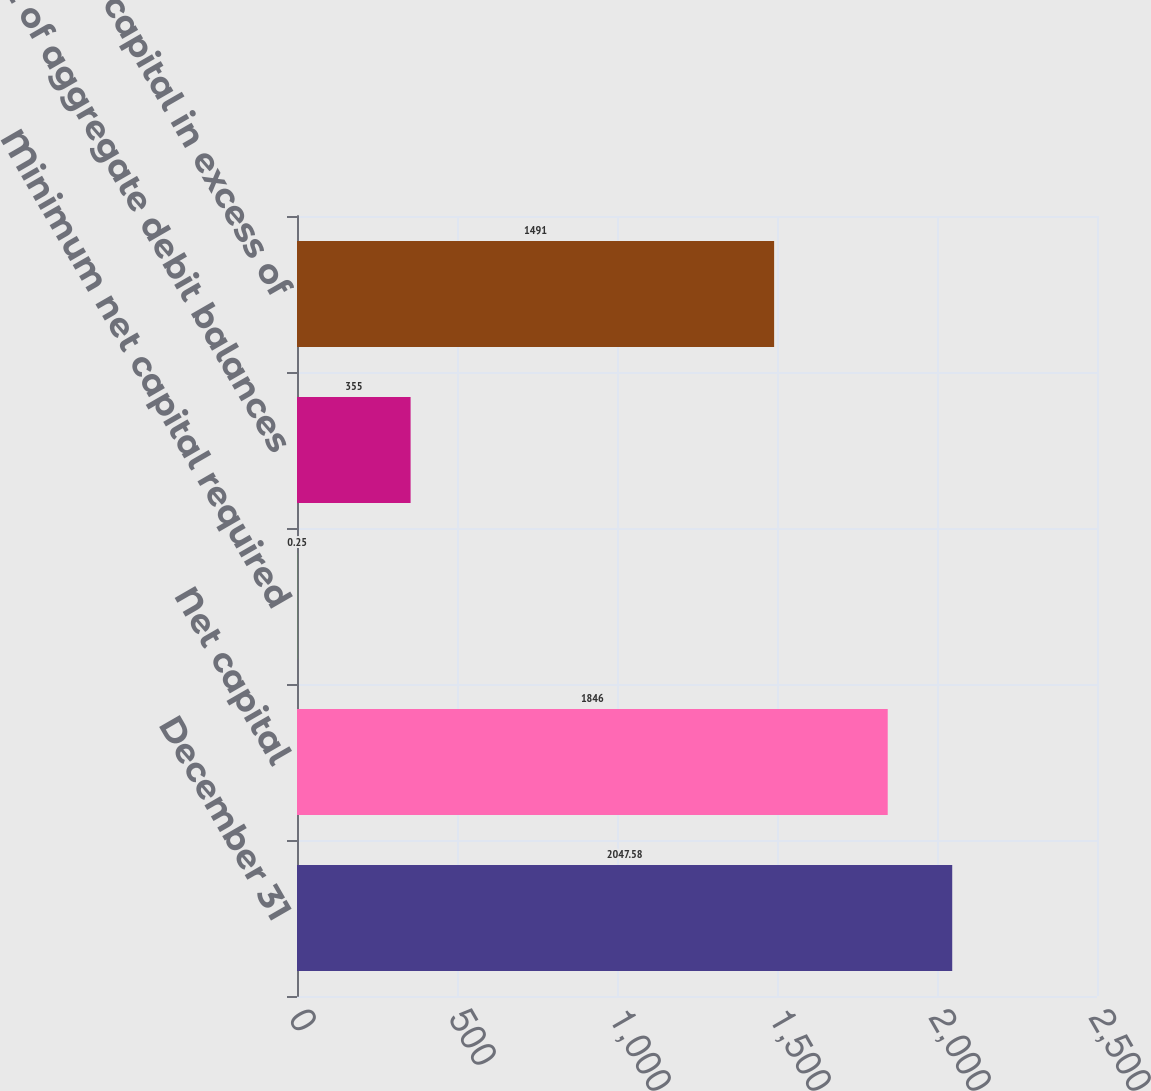Convert chart to OTSL. <chart><loc_0><loc_0><loc_500><loc_500><bar_chart><fcel>December 31<fcel>Net capital<fcel>Minimum net capital required<fcel>2 of aggregate debit balances<fcel>Net capital in excess of<nl><fcel>2047.58<fcel>1846<fcel>0.25<fcel>355<fcel>1491<nl></chart> 